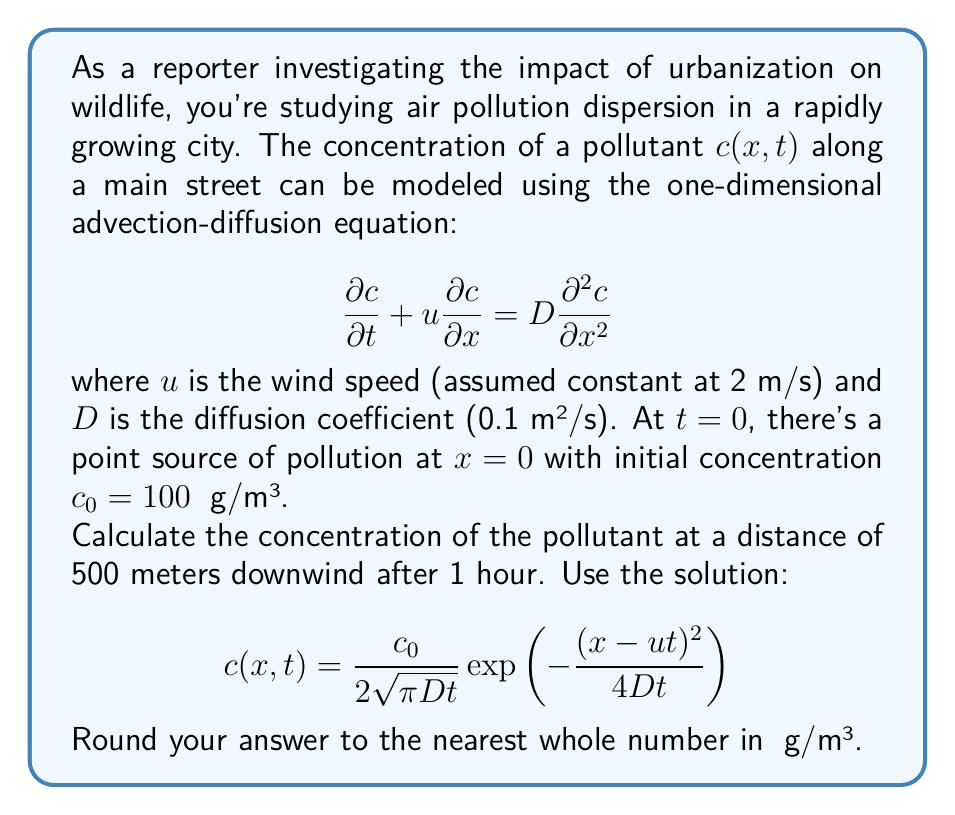Can you answer this question? To solve this problem, we'll follow these steps:

1) Identify the given parameters:
   $u = 2$ m/s (wind speed)
   $D = 0.1$ m²/s (diffusion coefficient)
   $c_0 = 100$ μg/m³ (initial concentration)
   $x = 500$ m (distance downwind)
   $t = 1$ hour = 3600 s (time elapsed)

2) Substitute these values into the solution equation:

   $$c(x,t) = \frac{100}{2\sqrt{\pi \cdot 0.1 \cdot 3600}}\exp\left(-\frac{(500-2\cdot3600)^2}{4\cdot0.1\cdot3600}\right)$$

3) Simplify the expression under the square root:
   $\sqrt{\pi \cdot 0.1 \cdot 3600} = \sqrt{360\pi} \approx 33.5410$

4) Simplify the expression in the exponent:
   $\frac{(500-2\cdot3600)^2}{4\cdot0.1\cdot3600} = \frac{(500-7200)^2}{1440} = \frac{(-6700)^2}{1440} \approx 31152.7778$

5) Now our equation looks like:

   $$c(500,3600) = \frac{100}{2 \cdot 33.5410}\exp(-31152.7778)$$

6) Calculate:
   $\frac{100}{2 \cdot 33.5410} \approx 1.4907$
   $\exp(-31152.7778) \approx 3.4135 \times 10^{-13543}$

7) Multiply:
   $1.4907 \cdot 3.4135 \times 10^{-13543} \approx 5.0878 \times 10^{-13543}$

8) Round to the nearest whole number:
   $5.0878 \times 10^{-13543} \approx 0$ μg/m³
Answer: 0 μg/m³ 